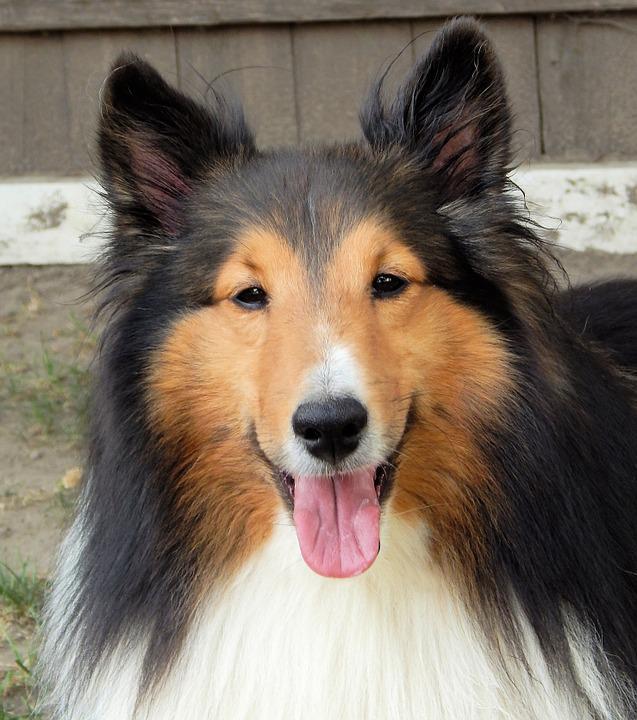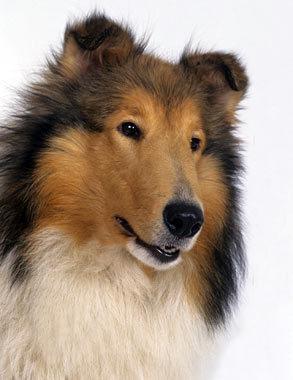The first image is the image on the left, the second image is the image on the right. Given the left and right images, does the statement "A collie is pictured on an outdoor light blue background." hold true? Answer yes or no. No. 